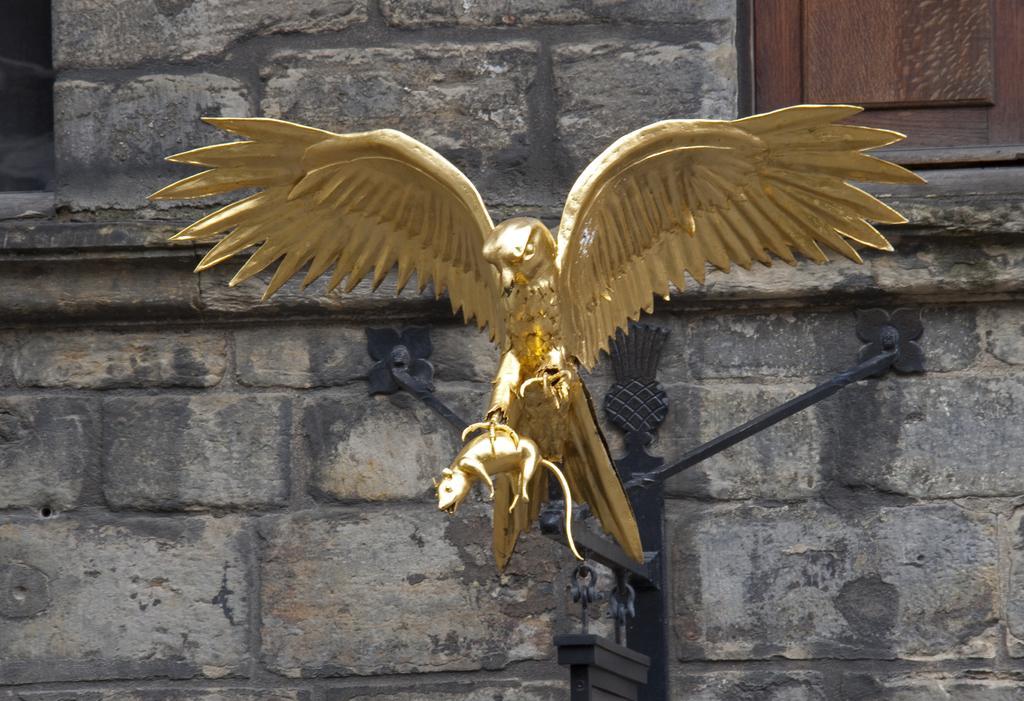Describe this image in one or two sentences. In this image there is a statue of a bird holding a mouse. In the background there is wall. This is a window. 